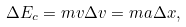Convert formula to latex. <formula><loc_0><loc_0><loc_500><loc_500>\Delta E _ { c } = m v \Delta v = m a \Delta x ,</formula> 